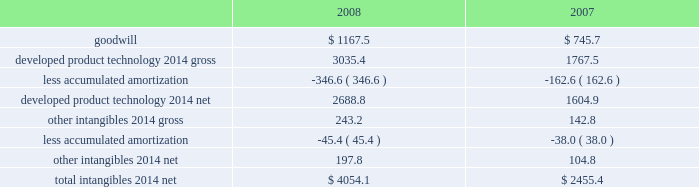On the underlying exposure .
For derivative contracts that are designated and qualify as cash fl ow hedges , the effective portion of gains and losses on these contracts is reported as a component of other comprehensive income and reclassifi ed into earnings in the same period the hedged transaction affects earnings .
Hedge ineffectiveness is immediately recognized in earnings .
Derivative contracts that are not designated as hedging instruments are recorded at fair value with the gain or loss recognized in current earnings during the period of change .
We may enter into foreign currency forward and option contracts to reduce the effect of fl uctuating currency exchange rates ( principally the euro , the british pound , and the japanese yen ) .
Foreign currency derivatives used for hedging are put in place using the same or like currencies and duration as the underlying exposures .
Forward contracts are principally used to manage exposures arising from subsidiary trade and loan payables and receivables denominated in foreign currencies .
These contracts are recorded at fair value with the gain or loss recognized in other 2014net .
The purchased option contracts are used to hedge anticipated foreign currency transactions , primarily intercompany inventory activities expected to occur within the next year .
These contracts are designated as cash fl ow hedges of those future transactions and the impact on earnings is included in cost of sales .
We may enter into foreign currency forward contracts and currency swaps as fair value hedges of fi rm commitments .
Forward and option contracts generally have maturities not exceeding 12 months .
In the normal course of business , our operations are exposed to fl uctuations in interest rates .
These fl uctuations can vary the costs of fi nancing , investing , and operating .
We address a portion of these risks through a controlled program of risk management that includes the use of derivative fi nancial instruments .
The objective of controlling these risks is to limit the impact of fl uctuations in interest rates on earnings .
Our primary interest rate risk exposure results from changes in short-term u.s .
Dollar interest rates .
In an effort to manage interest rate exposures , we strive to achieve an acceptable balance between fi xed and fl oating rate debt and investment positions and may enter into interest rate swaps or collars to help maintain that balance .
Interest rate swaps or collars that convert our fi xed- rate debt or investments to a fl oating rate are designated as fair value hedges of the underlying instruments .
Interest rate swaps or collars that convert fl oating rate debt or investments to a fi xed rate are designated as cash fl ow hedg- es .
Interest expense on the debt is adjusted to include the payments made or received under the swap agreements .
Goodwill and other intangibles : goodwill is not amortized .
All other intangibles arising from acquisitions and research alliances have fi nite lives and are amortized over their estimated useful lives , ranging from 5 to 20 years , using the straight-line method .
The weighted-average amortization period for developed product technology is approximately 12 years .
Amortization expense for 2008 , 2007 , and 2006 was $ 193.4 million , $ 172.8 million , and $ 7.6 million before tax , respectively .
The estimated amortization expense for each of the fi ve succeeding years approximates $ 280 million before tax , per year .
Substantially all of the amortization expense is included in cost of sales .
See note 3 for further discussion of goodwill and other intangibles acquired in 2008 and 2007 .
Goodwill and other intangible assets at december 31 were as follows: .
Goodwill and net other intangibles are reviewed to assess recoverability at least annually and when certain impairment indicators are present .
No signifi cant impairments occurred with respect to the carrying value of our goodwill or other intangible assets in 2008 , 2007 , or 2006 .
Property and equipment : property and equipment is stated on the basis of cost .
Provisions for depreciation of buildings and equipment are computed generally by the straight-line method at rates based on their estimated useful lives ( 12 to 50 years for buildings and 3 to 18 years for equipment ) .
We review the carrying value of long-lived assets for potential impairment on a periodic basis and whenever events or changes in circumstances indicate the .
What was the percent of increase in the amortization expense from 2007 to 2008? 
Rationale: the percent of increase in the amortization expense from 2007 to 2008 was 11.9%
Computations: ((193.4 - 172.8) / 172.8)
Answer: 0.11921. 